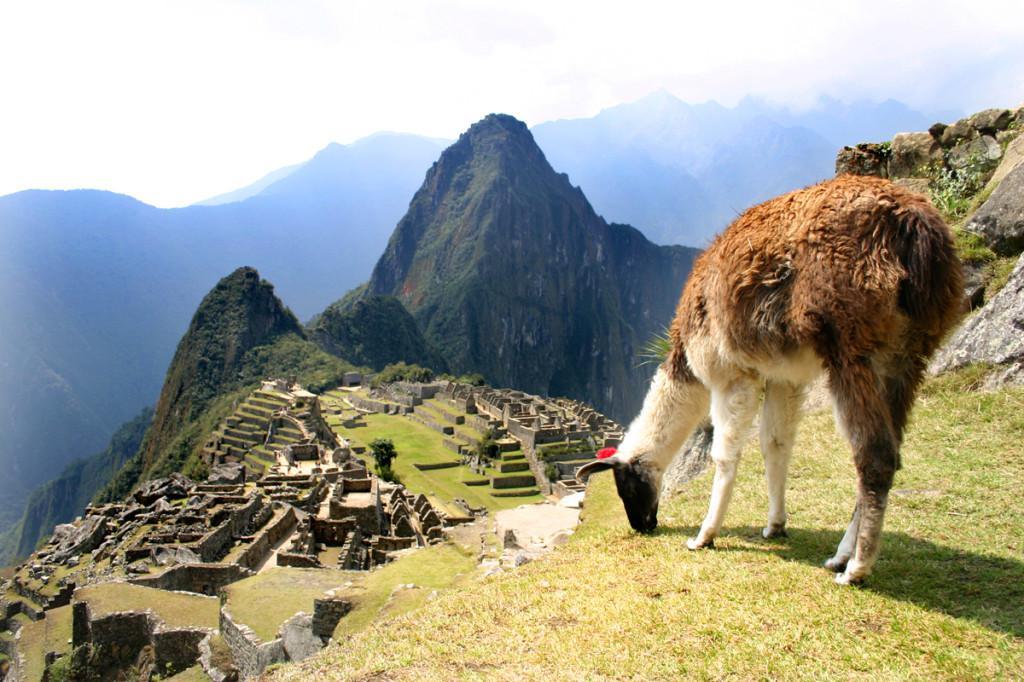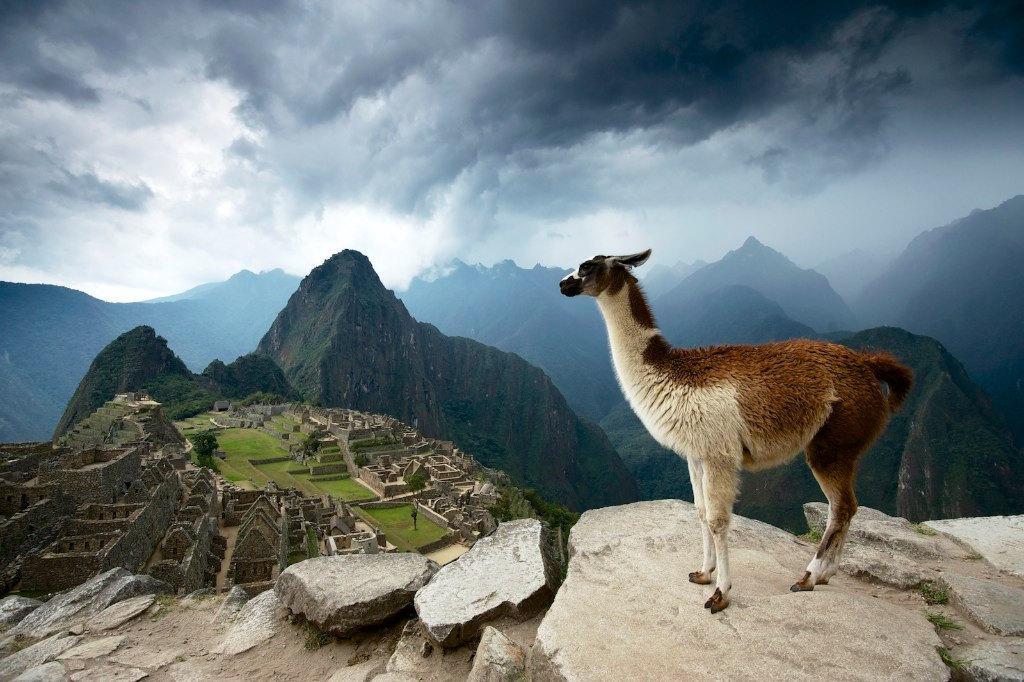The first image is the image on the left, the second image is the image on the right. For the images displayed, is the sentence "The left image features a llama with head angled forward, standing in the foreground on the left, with mountains and mazelike structures behind it." factually correct? Answer yes or no. No. The first image is the image on the left, the second image is the image on the right. Analyze the images presented: Is the assertion "In at least one image there is a single white and brown lama with their neck extended and a green hill and one stone mountain peak to the right of them." valid? Answer yes or no. No. 